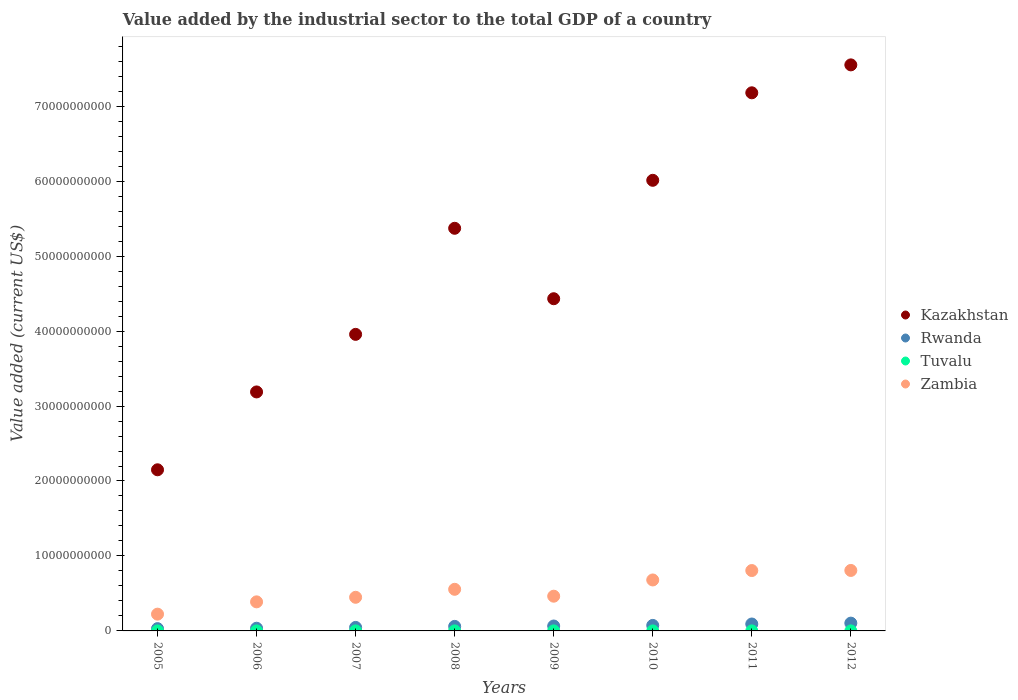How many different coloured dotlines are there?
Ensure brevity in your answer.  4. Is the number of dotlines equal to the number of legend labels?
Make the answer very short. Yes. What is the value added by the industrial sector to the total GDP in Kazakhstan in 2012?
Your response must be concise. 7.55e+1. Across all years, what is the maximum value added by the industrial sector to the total GDP in Zambia?
Offer a terse response. 8.07e+09. Across all years, what is the minimum value added by the industrial sector to the total GDP in Zambia?
Ensure brevity in your answer.  2.24e+09. What is the total value added by the industrial sector to the total GDP in Rwanda in the graph?
Your response must be concise. 5.09e+09. What is the difference between the value added by the industrial sector to the total GDP in Kazakhstan in 2009 and that in 2010?
Ensure brevity in your answer.  -1.58e+1. What is the difference between the value added by the industrial sector to the total GDP in Tuvalu in 2012 and the value added by the industrial sector to the total GDP in Rwanda in 2009?
Ensure brevity in your answer.  -6.52e+08. What is the average value added by the industrial sector to the total GDP in Rwanda per year?
Offer a very short reply. 6.36e+08. In the year 2006, what is the difference between the value added by the industrial sector to the total GDP in Zambia and value added by the industrial sector to the total GDP in Tuvalu?
Ensure brevity in your answer.  3.88e+09. In how many years, is the value added by the industrial sector to the total GDP in Kazakhstan greater than 24000000000 US$?
Your answer should be compact. 7. What is the ratio of the value added by the industrial sector to the total GDP in Tuvalu in 2005 to that in 2007?
Ensure brevity in your answer.  0.8. What is the difference between the highest and the second highest value added by the industrial sector to the total GDP in Kazakhstan?
Give a very brief answer. 3.73e+09. What is the difference between the highest and the lowest value added by the industrial sector to the total GDP in Kazakhstan?
Ensure brevity in your answer.  5.40e+1. Is it the case that in every year, the sum of the value added by the industrial sector to the total GDP in Kazakhstan and value added by the industrial sector to the total GDP in Rwanda  is greater than the value added by the industrial sector to the total GDP in Zambia?
Offer a terse response. Yes. Does the value added by the industrial sector to the total GDP in Tuvalu monotonically increase over the years?
Ensure brevity in your answer.  No. How many dotlines are there?
Provide a succinct answer. 4. What is the difference between two consecutive major ticks on the Y-axis?
Offer a terse response. 1.00e+1. Are the values on the major ticks of Y-axis written in scientific E-notation?
Make the answer very short. No. Does the graph contain any zero values?
Make the answer very short. No. Where does the legend appear in the graph?
Ensure brevity in your answer.  Center right. How many legend labels are there?
Give a very brief answer. 4. How are the legend labels stacked?
Offer a terse response. Vertical. What is the title of the graph?
Keep it short and to the point. Value added by the industrial sector to the total GDP of a country. Does "Europe(all income levels)" appear as one of the legend labels in the graph?
Make the answer very short. No. What is the label or title of the Y-axis?
Offer a terse response. Value added (current US$). What is the Value added (current US$) in Kazakhstan in 2005?
Your response must be concise. 2.15e+1. What is the Value added (current US$) in Rwanda in 2005?
Your answer should be compact. 3.05e+08. What is the Value added (current US$) in Tuvalu in 2005?
Your answer should be compact. 1.70e+06. What is the Value added (current US$) in Zambia in 2005?
Keep it short and to the point. 2.24e+09. What is the Value added (current US$) in Kazakhstan in 2006?
Your answer should be compact. 3.19e+1. What is the Value added (current US$) in Rwanda in 2006?
Provide a succinct answer. 3.59e+08. What is the Value added (current US$) in Tuvalu in 2006?
Your answer should be very brief. 1.30e+06. What is the Value added (current US$) in Zambia in 2006?
Offer a very short reply. 3.88e+09. What is the Value added (current US$) of Kazakhstan in 2007?
Your answer should be compact. 3.96e+1. What is the Value added (current US$) in Rwanda in 2007?
Provide a short and direct response. 4.68e+08. What is the Value added (current US$) in Tuvalu in 2007?
Your answer should be compact. 2.12e+06. What is the Value added (current US$) in Zambia in 2007?
Your response must be concise. 4.49e+09. What is the Value added (current US$) of Kazakhstan in 2008?
Keep it short and to the point. 5.37e+1. What is the Value added (current US$) in Rwanda in 2008?
Ensure brevity in your answer.  6.05e+08. What is the Value added (current US$) of Tuvalu in 2008?
Provide a succinct answer. 3.91e+06. What is the Value added (current US$) of Zambia in 2008?
Provide a succinct answer. 5.55e+09. What is the Value added (current US$) of Kazakhstan in 2009?
Provide a short and direct response. 4.43e+1. What is the Value added (current US$) in Rwanda in 2009?
Provide a short and direct response. 6.55e+08. What is the Value added (current US$) of Tuvalu in 2009?
Your response must be concise. 3.10e+06. What is the Value added (current US$) in Zambia in 2009?
Provide a succinct answer. 4.63e+09. What is the Value added (current US$) in Kazakhstan in 2010?
Your answer should be very brief. 6.01e+1. What is the Value added (current US$) in Rwanda in 2010?
Offer a very short reply. 7.34e+08. What is the Value added (current US$) in Tuvalu in 2010?
Provide a short and direct response. 1.77e+06. What is the Value added (current US$) in Zambia in 2010?
Make the answer very short. 6.80e+09. What is the Value added (current US$) of Kazakhstan in 2011?
Provide a short and direct response. 7.18e+1. What is the Value added (current US$) of Rwanda in 2011?
Your answer should be very brief. 9.23e+08. What is the Value added (current US$) of Tuvalu in 2011?
Keep it short and to the point. 3.49e+06. What is the Value added (current US$) in Zambia in 2011?
Give a very brief answer. 8.05e+09. What is the Value added (current US$) of Kazakhstan in 2012?
Make the answer very short. 7.55e+1. What is the Value added (current US$) in Rwanda in 2012?
Keep it short and to the point. 1.04e+09. What is the Value added (current US$) in Tuvalu in 2012?
Make the answer very short. 2.17e+06. What is the Value added (current US$) in Zambia in 2012?
Your response must be concise. 8.07e+09. Across all years, what is the maximum Value added (current US$) of Kazakhstan?
Ensure brevity in your answer.  7.55e+1. Across all years, what is the maximum Value added (current US$) in Rwanda?
Provide a short and direct response. 1.04e+09. Across all years, what is the maximum Value added (current US$) in Tuvalu?
Offer a terse response. 3.91e+06. Across all years, what is the maximum Value added (current US$) of Zambia?
Your answer should be very brief. 8.07e+09. Across all years, what is the minimum Value added (current US$) in Kazakhstan?
Your response must be concise. 2.15e+1. Across all years, what is the minimum Value added (current US$) of Rwanda?
Keep it short and to the point. 3.05e+08. Across all years, what is the minimum Value added (current US$) of Tuvalu?
Offer a terse response. 1.30e+06. Across all years, what is the minimum Value added (current US$) of Zambia?
Keep it short and to the point. 2.24e+09. What is the total Value added (current US$) in Kazakhstan in the graph?
Provide a succinct answer. 3.98e+11. What is the total Value added (current US$) in Rwanda in the graph?
Offer a very short reply. 5.09e+09. What is the total Value added (current US$) in Tuvalu in the graph?
Offer a very short reply. 1.96e+07. What is the total Value added (current US$) in Zambia in the graph?
Ensure brevity in your answer.  4.37e+1. What is the difference between the Value added (current US$) in Kazakhstan in 2005 and that in 2006?
Make the answer very short. -1.04e+1. What is the difference between the Value added (current US$) of Rwanda in 2005 and that in 2006?
Make the answer very short. -5.41e+07. What is the difference between the Value added (current US$) of Tuvalu in 2005 and that in 2006?
Your answer should be compact. 3.97e+05. What is the difference between the Value added (current US$) of Zambia in 2005 and that in 2006?
Your answer should be compact. -1.64e+09. What is the difference between the Value added (current US$) in Kazakhstan in 2005 and that in 2007?
Provide a succinct answer. -1.81e+1. What is the difference between the Value added (current US$) in Rwanda in 2005 and that in 2007?
Provide a short and direct response. -1.63e+08. What is the difference between the Value added (current US$) in Tuvalu in 2005 and that in 2007?
Offer a very short reply. -4.18e+05. What is the difference between the Value added (current US$) in Zambia in 2005 and that in 2007?
Offer a very short reply. -2.25e+09. What is the difference between the Value added (current US$) of Kazakhstan in 2005 and that in 2008?
Your response must be concise. -3.22e+1. What is the difference between the Value added (current US$) of Rwanda in 2005 and that in 2008?
Provide a succinct answer. -3.01e+08. What is the difference between the Value added (current US$) of Tuvalu in 2005 and that in 2008?
Provide a short and direct response. -2.21e+06. What is the difference between the Value added (current US$) of Zambia in 2005 and that in 2008?
Your response must be concise. -3.31e+09. What is the difference between the Value added (current US$) in Kazakhstan in 2005 and that in 2009?
Your response must be concise. -2.28e+1. What is the difference between the Value added (current US$) of Rwanda in 2005 and that in 2009?
Make the answer very short. -3.50e+08. What is the difference between the Value added (current US$) in Tuvalu in 2005 and that in 2009?
Give a very brief answer. -1.40e+06. What is the difference between the Value added (current US$) in Zambia in 2005 and that in 2009?
Ensure brevity in your answer.  -2.40e+09. What is the difference between the Value added (current US$) of Kazakhstan in 2005 and that in 2010?
Offer a very short reply. -3.86e+1. What is the difference between the Value added (current US$) of Rwanda in 2005 and that in 2010?
Make the answer very short. -4.29e+08. What is the difference between the Value added (current US$) of Tuvalu in 2005 and that in 2010?
Offer a terse response. -7.46e+04. What is the difference between the Value added (current US$) in Zambia in 2005 and that in 2010?
Make the answer very short. -4.56e+09. What is the difference between the Value added (current US$) of Kazakhstan in 2005 and that in 2011?
Ensure brevity in your answer.  -5.03e+1. What is the difference between the Value added (current US$) of Rwanda in 2005 and that in 2011?
Provide a short and direct response. -6.18e+08. What is the difference between the Value added (current US$) in Tuvalu in 2005 and that in 2011?
Provide a succinct answer. -1.79e+06. What is the difference between the Value added (current US$) of Zambia in 2005 and that in 2011?
Ensure brevity in your answer.  -5.82e+09. What is the difference between the Value added (current US$) in Kazakhstan in 2005 and that in 2012?
Give a very brief answer. -5.40e+1. What is the difference between the Value added (current US$) of Rwanda in 2005 and that in 2012?
Your answer should be compact. -7.34e+08. What is the difference between the Value added (current US$) of Tuvalu in 2005 and that in 2012?
Your answer should be very brief. -4.67e+05. What is the difference between the Value added (current US$) in Zambia in 2005 and that in 2012?
Provide a short and direct response. -5.83e+09. What is the difference between the Value added (current US$) in Kazakhstan in 2006 and that in 2007?
Your answer should be very brief. -7.68e+09. What is the difference between the Value added (current US$) in Rwanda in 2006 and that in 2007?
Keep it short and to the point. -1.09e+08. What is the difference between the Value added (current US$) in Tuvalu in 2006 and that in 2007?
Your answer should be very brief. -8.15e+05. What is the difference between the Value added (current US$) of Zambia in 2006 and that in 2007?
Offer a terse response. -6.08e+08. What is the difference between the Value added (current US$) in Kazakhstan in 2006 and that in 2008?
Your answer should be compact. -2.18e+1. What is the difference between the Value added (current US$) of Rwanda in 2006 and that in 2008?
Provide a succinct answer. -2.46e+08. What is the difference between the Value added (current US$) in Tuvalu in 2006 and that in 2008?
Ensure brevity in your answer.  -2.61e+06. What is the difference between the Value added (current US$) of Zambia in 2006 and that in 2008?
Make the answer very short. -1.67e+09. What is the difference between the Value added (current US$) of Kazakhstan in 2006 and that in 2009?
Make the answer very short. -1.24e+1. What is the difference between the Value added (current US$) of Rwanda in 2006 and that in 2009?
Provide a short and direct response. -2.96e+08. What is the difference between the Value added (current US$) of Tuvalu in 2006 and that in 2009?
Ensure brevity in your answer.  -1.80e+06. What is the difference between the Value added (current US$) in Zambia in 2006 and that in 2009?
Provide a short and direct response. -7.55e+08. What is the difference between the Value added (current US$) of Kazakhstan in 2006 and that in 2010?
Make the answer very short. -2.82e+1. What is the difference between the Value added (current US$) of Rwanda in 2006 and that in 2010?
Provide a succinct answer. -3.75e+08. What is the difference between the Value added (current US$) of Tuvalu in 2006 and that in 2010?
Your answer should be very brief. -4.72e+05. What is the difference between the Value added (current US$) in Zambia in 2006 and that in 2010?
Your answer should be compact. -2.92e+09. What is the difference between the Value added (current US$) of Kazakhstan in 2006 and that in 2011?
Ensure brevity in your answer.  -3.99e+1. What is the difference between the Value added (current US$) in Rwanda in 2006 and that in 2011?
Your answer should be very brief. -5.64e+08. What is the difference between the Value added (current US$) in Tuvalu in 2006 and that in 2011?
Offer a terse response. -2.18e+06. What is the difference between the Value added (current US$) of Zambia in 2006 and that in 2011?
Provide a succinct answer. -4.18e+09. What is the difference between the Value added (current US$) in Kazakhstan in 2006 and that in 2012?
Give a very brief answer. -4.36e+1. What is the difference between the Value added (current US$) in Rwanda in 2006 and that in 2012?
Offer a terse response. -6.80e+08. What is the difference between the Value added (current US$) in Tuvalu in 2006 and that in 2012?
Offer a terse response. -8.64e+05. What is the difference between the Value added (current US$) of Zambia in 2006 and that in 2012?
Keep it short and to the point. -4.19e+09. What is the difference between the Value added (current US$) of Kazakhstan in 2007 and that in 2008?
Ensure brevity in your answer.  -1.41e+1. What is the difference between the Value added (current US$) in Rwanda in 2007 and that in 2008?
Your response must be concise. -1.37e+08. What is the difference between the Value added (current US$) of Tuvalu in 2007 and that in 2008?
Your answer should be very brief. -1.79e+06. What is the difference between the Value added (current US$) of Zambia in 2007 and that in 2008?
Ensure brevity in your answer.  -1.07e+09. What is the difference between the Value added (current US$) in Kazakhstan in 2007 and that in 2009?
Your response must be concise. -4.75e+09. What is the difference between the Value added (current US$) in Rwanda in 2007 and that in 2009?
Ensure brevity in your answer.  -1.87e+08. What is the difference between the Value added (current US$) of Tuvalu in 2007 and that in 2009?
Keep it short and to the point. -9.82e+05. What is the difference between the Value added (current US$) of Zambia in 2007 and that in 2009?
Your answer should be compact. -1.47e+08. What is the difference between the Value added (current US$) of Kazakhstan in 2007 and that in 2010?
Offer a terse response. -2.06e+1. What is the difference between the Value added (current US$) in Rwanda in 2007 and that in 2010?
Provide a succinct answer. -2.66e+08. What is the difference between the Value added (current US$) in Tuvalu in 2007 and that in 2010?
Give a very brief answer. 3.43e+05. What is the difference between the Value added (current US$) of Zambia in 2007 and that in 2010?
Give a very brief answer. -2.31e+09. What is the difference between the Value added (current US$) of Kazakhstan in 2007 and that in 2011?
Provide a succinct answer. -3.22e+1. What is the difference between the Value added (current US$) in Rwanda in 2007 and that in 2011?
Provide a succinct answer. -4.55e+08. What is the difference between the Value added (current US$) of Tuvalu in 2007 and that in 2011?
Your answer should be very brief. -1.37e+06. What is the difference between the Value added (current US$) in Zambia in 2007 and that in 2011?
Your response must be concise. -3.57e+09. What is the difference between the Value added (current US$) of Kazakhstan in 2007 and that in 2012?
Ensure brevity in your answer.  -3.59e+1. What is the difference between the Value added (current US$) in Rwanda in 2007 and that in 2012?
Your answer should be very brief. -5.71e+08. What is the difference between the Value added (current US$) of Tuvalu in 2007 and that in 2012?
Your response must be concise. -4.91e+04. What is the difference between the Value added (current US$) in Zambia in 2007 and that in 2012?
Ensure brevity in your answer.  -3.58e+09. What is the difference between the Value added (current US$) of Kazakhstan in 2008 and that in 2009?
Provide a short and direct response. 9.40e+09. What is the difference between the Value added (current US$) in Rwanda in 2008 and that in 2009?
Give a very brief answer. -4.93e+07. What is the difference between the Value added (current US$) in Tuvalu in 2008 and that in 2009?
Provide a succinct answer. 8.09e+05. What is the difference between the Value added (current US$) in Zambia in 2008 and that in 2009?
Your response must be concise. 9.18e+08. What is the difference between the Value added (current US$) in Kazakhstan in 2008 and that in 2010?
Ensure brevity in your answer.  -6.40e+09. What is the difference between the Value added (current US$) of Rwanda in 2008 and that in 2010?
Your response must be concise. -1.29e+08. What is the difference between the Value added (current US$) in Tuvalu in 2008 and that in 2010?
Offer a terse response. 2.13e+06. What is the difference between the Value added (current US$) in Zambia in 2008 and that in 2010?
Your response must be concise. -1.25e+09. What is the difference between the Value added (current US$) of Kazakhstan in 2008 and that in 2011?
Provide a succinct answer. -1.81e+1. What is the difference between the Value added (current US$) in Rwanda in 2008 and that in 2011?
Make the answer very short. -3.18e+08. What is the difference between the Value added (current US$) of Tuvalu in 2008 and that in 2011?
Offer a terse response. 4.23e+05. What is the difference between the Value added (current US$) of Zambia in 2008 and that in 2011?
Make the answer very short. -2.50e+09. What is the difference between the Value added (current US$) of Kazakhstan in 2008 and that in 2012?
Your answer should be compact. -2.18e+1. What is the difference between the Value added (current US$) in Rwanda in 2008 and that in 2012?
Keep it short and to the point. -4.33e+08. What is the difference between the Value added (current US$) in Tuvalu in 2008 and that in 2012?
Ensure brevity in your answer.  1.74e+06. What is the difference between the Value added (current US$) of Zambia in 2008 and that in 2012?
Keep it short and to the point. -2.52e+09. What is the difference between the Value added (current US$) in Kazakhstan in 2009 and that in 2010?
Your answer should be very brief. -1.58e+1. What is the difference between the Value added (current US$) in Rwanda in 2009 and that in 2010?
Provide a succinct answer. -7.94e+07. What is the difference between the Value added (current US$) in Tuvalu in 2009 and that in 2010?
Your answer should be very brief. 1.33e+06. What is the difference between the Value added (current US$) in Zambia in 2009 and that in 2010?
Your answer should be compact. -2.16e+09. What is the difference between the Value added (current US$) in Kazakhstan in 2009 and that in 2011?
Offer a terse response. -2.75e+1. What is the difference between the Value added (current US$) in Rwanda in 2009 and that in 2011?
Provide a succinct answer. -2.68e+08. What is the difference between the Value added (current US$) of Tuvalu in 2009 and that in 2011?
Give a very brief answer. -3.86e+05. What is the difference between the Value added (current US$) of Zambia in 2009 and that in 2011?
Provide a short and direct response. -3.42e+09. What is the difference between the Value added (current US$) of Kazakhstan in 2009 and that in 2012?
Give a very brief answer. -3.12e+1. What is the difference between the Value added (current US$) of Rwanda in 2009 and that in 2012?
Your answer should be very brief. -3.84e+08. What is the difference between the Value added (current US$) in Tuvalu in 2009 and that in 2012?
Provide a succinct answer. 9.33e+05. What is the difference between the Value added (current US$) in Zambia in 2009 and that in 2012?
Ensure brevity in your answer.  -3.43e+09. What is the difference between the Value added (current US$) in Kazakhstan in 2010 and that in 2011?
Provide a succinct answer. -1.17e+1. What is the difference between the Value added (current US$) of Rwanda in 2010 and that in 2011?
Make the answer very short. -1.89e+08. What is the difference between the Value added (current US$) of Tuvalu in 2010 and that in 2011?
Your answer should be compact. -1.71e+06. What is the difference between the Value added (current US$) in Zambia in 2010 and that in 2011?
Ensure brevity in your answer.  -1.26e+09. What is the difference between the Value added (current US$) in Kazakhstan in 2010 and that in 2012?
Offer a terse response. -1.54e+1. What is the difference between the Value added (current US$) in Rwanda in 2010 and that in 2012?
Keep it short and to the point. -3.05e+08. What is the difference between the Value added (current US$) in Tuvalu in 2010 and that in 2012?
Your response must be concise. -3.92e+05. What is the difference between the Value added (current US$) of Zambia in 2010 and that in 2012?
Your response must be concise. -1.27e+09. What is the difference between the Value added (current US$) in Kazakhstan in 2011 and that in 2012?
Your answer should be very brief. -3.73e+09. What is the difference between the Value added (current US$) of Rwanda in 2011 and that in 2012?
Provide a succinct answer. -1.16e+08. What is the difference between the Value added (current US$) in Tuvalu in 2011 and that in 2012?
Your answer should be very brief. 1.32e+06. What is the difference between the Value added (current US$) of Zambia in 2011 and that in 2012?
Offer a very short reply. -1.27e+07. What is the difference between the Value added (current US$) in Kazakhstan in 2005 and the Value added (current US$) in Rwanda in 2006?
Your answer should be very brief. 2.11e+1. What is the difference between the Value added (current US$) of Kazakhstan in 2005 and the Value added (current US$) of Tuvalu in 2006?
Your answer should be compact. 2.15e+1. What is the difference between the Value added (current US$) in Kazakhstan in 2005 and the Value added (current US$) in Zambia in 2006?
Your response must be concise. 1.76e+1. What is the difference between the Value added (current US$) in Rwanda in 2005 and the Value added (current US$) in Tuvalu in 2006?
Provide a short and direct response. 3.03e+08. What is the difference between the Value added (current US$) of Rwanda in 2005 and the Value added (current US$) of Zambia in 2006?
Provide a short and direct response. -3.57e+09. What is the difference between the Value added (current US$) in Tuvalu in 2005 and the Value added (current US$) in Zambia in 2006?
Make the answer very short. -3.88e+09. What is the difference between the Value added (current US$) in Kazakhstan in 2005 and the Value added (current US$) in Rwanda in 2007?
Provide a succinct answer. 2.10e+1. What is the difference between the Value added (current US$) in Kazakhstan in 2005 and the Value added (current US$) in Tuvalu in 2007?
Give a very brief answer. 2.15e+1. What is the difference between the Value added (current US$) in Kazakhstan in 2005 and the Value added (current US$) in Zambia in 2007?
Keep it short and to the point. 1.70e+1. What is the difference between the Value added (current US$) in Rwanda in 2005 and the Value added (current US$) in Tuvalu in 2007?
Your answer should be very brief. 3.03e+08. What is the difference between the Value added (current US$) in Rwanda in 2005 and the Value added (current US$) in Zambia in 2007?
Ensure brevity in your answer.  -4.18e+09. What is the difference between the Value added (current US$) of Tuvalu in 2005 and the Value added (current US$) of Zambia in 2007?
Make the answer very short. -4.48e+09. What is the difference between the Value added (current US$) in Kazakhstan in 2005 and the Value added (current US$) in Rwanda in 2008?
Give a very brief answer. 2.09e+1. What is the difference between the Value added (current US$) in Kazakhstan in 2005 and the Value added (current US$) in Tuvalu in 2008?
Your answer should be very brief. 2.15e+1. What is the difference between the Value added (current US$) of Kazakhstan in 2005 and the Value added (current US$) of Zambia in 2008?
Your answer should be very brief. 1.59e+1. What is the difference between the Value added (current US$) of Rwanda in 2005 and the Value added (current US$) of Tuvalu in 2008?
Ensure brevity in your answer.  3.01e+08. What is the difference between the Value added (current US$) of Rwanda in 2005 and the Value added (current US$) of Zambia in 2008?
Offer a very short reply. -5.25e+09. What is the difference between the Value added (current US$) in Tuvalu in 2005 and the Value added (current US$) in Zambia in 2008?
Give a very brief answer. -5.55e+09. What is the difference between the Value added (current US$) of Kazakhstan in 2005 and the Value added (current US$) of Rwanda in 2009?
Keep it short and to the point. 2.08e+1. What is the difference between the Value added (current US$) of Kazakhstan in 2005 and the Value added (current US$) of Tuvalu in 2009?
Offer a very short reply. 2.15e+1. What is the difference between the Value added (current US$) of Kazakhstan in 2005 and the Value added (current US$) of Zambia in 2009?
Offer a terse response. 1.69e+1. What is the difference between the Value added (current US$) of Rwanda in 2005 and the Value added (current US$) of Tuvalu in 2009?
Ensure brevity in your answer.  3.02e+08. What is the difference between the Value added (current US$) of Rwanda in 2005 and the Value added (current US$) of Zambia in 2009?
Your answer should be compact. -4.33e+09. What is the difference between the Value added (current US$) of Tuvalu in 2005 and the Value added (current US$) of Zambia in 2009?
Provide a short and direct response. -4.63e+09. What is the difference between the Value added (current US$) of Kazakhstan in 2005 and the Value added (current US$) of Rwanda in 2010?
Ensure brevity in your answer.  2.08e+1. What is the difference between the Value added (current US$) of Kazakhstan in 2005 and the Value added (current US$) of Tuvalu in 2010?
Your answer should be compact. 2.15e+1. What is the difference between the Value added (current US$) of Kazakhstan in 2005 and the Value added (current US$) of Zambia in 2010?
Offer a terse response. 1.47e+1. What is the difference between the Value added (current US$) in Rwanda in 2005 and the Value added (current US$) in Tuvalu in 2010?
Your response must be concise. 3.03e+08. What is the difference between the Value added (current US$) in Rwanda in 2005 and the Value added (current US$) in Zambia in 2010?
Offer a very short reply. -6.49e+09. What is the difference between the Value added (current US$) of Tuvalu in 2005 and the Value added (current US$) of Zambia in 2010?
Your response must be concise. -6.80e+09. What is the difference between the Value added (current US$) in Kazakhstan in 2005 and the Value added (current US$) in Rwanda in 2011?
Provide a short and direct response. 2.06e+1. What is the difference between the Value added (current US$) in Kazakhstan in 2005 and the Value added (current US$) in Tuvalu in 2011?
Offer a terse response. 2.15e+1. What is the difference between the Value added (current US$) of Kazakhstan in 2005 and the Value added (current US$) of Zambia in 2011?
Ensure brevity in your answer.  1.34e+1. What is the difference between the Value added (current US$) in Rwanda in 2005 and the Value added (current US$) in Tuvalu in 2011?
Ensure brevity in your answer.  3.01e+08. What is the difference between the Value added (current US$) in Rwanda in 2005 and the Value added (current US$) in Zambia in 2011?
Provide a short and direct response. -7.75e+09. What is the difference between the Value added (current US$) in Tuvalu in 2005 and the Value added (current US$) in Zambia in 2011?
Ensure brevity in your answer.  -8.05e+09. What is the difference between the Value added (current US$) in Kazakhstan in 2005 and the Value added (current US$) in Rwanda in 2012?
Ensure brevity in your answer.  2.05e+1. What is the difference between the Value added (current US$) in Kazakhstan in 2005 and the Value added (current US$) in Tuvalu in 2012?
Ensure brevity in your answer.  2.15e+1. What is the difference between the Value added (current US$) in Kazakhstan in 2005 and the Value added (current US$) in Zambia in 2012?
Your answer should be compact. 1.34e+1. What is the difference between the Value added (current US$) of Rwanda in 2005 and the Value added (current US$) of Tuvalu in 2012?
Make the answer very short. 3.03e+08. What is the difference between the Value added (current US$) in Rwanda in 2005 and the Value added (current US$) in Zambia in 2012?
Your answer should be very brief. -7.76e+09. What is the difference between the Value added (current US$) of Tuvalu in 2005 and the Value added (current US$) of Zambia in 2012?
Provide a succinct answer. -8.07e+09. What is the difference between the Value added (current US$) of Kazakhstan in 2006 and the Value added (current US$) of Rwanda in 2007?
Provide a succinct answer. 3.14e+1. What is the difference between the Value added (current US$) in Kazakhstan in 2006 and the Value added (current US$) in Tuvalu in 2007?
Offer a very short reply. 3.19e+1. What is the difference between the Value added (current US$) of Kazakhstan in 2006 and the Value added (current US$) of Zambia in 2007?
Provide a succinct answer. 2.74e+1. What is the difference between the Value added (current US$) in Rwanda in 2006 and the Value added (current US$) in Tuvalu in 2007?
Your answer should be compact. 3.57e+08. What is the difference between the Value added (current US$) in Rwanda in 2006 and the Value added (current US$) in Zambia in 2007?
Provide a succinct answer. -4.13e+09. What is the difference between the Value added (current US$) in Tuvalu in 2006 and the Value added (current US$) in Zambia in 2007?
Make the answer very short. -4.48e+09. What is the difference between the Value added (current US$) in Kazakhstan in 2006 and the Value added (current US$) in Rwanda in 2008?
Your answer should be compact. 3.13e+1. What is the difference between the Value added (current US$) in Kazakhstan in 2006 and the Value added (current US$) in Tuvalu in 2008?
Make the answer very short. 3.19e+1. What is the difference between the Value added (current US$) of Kazakhstan in 2006 and the Value added (current US$) of Zambia in 2008?
Provide a short and direct response. 2.63e+1. What is the difference between the Value added (current US$) in Rwanda in 2006 and the Value added (current US$) in Tuvalu in 2008?
Offer a terse response. 3.55e+08. What is the difference between the Value added (current US$) in Rwanda in 2006 and the Value added (current US$) in Zambia in 2008?
Ensure brevity in your answer.  -5.19e+09. What is the difference between the Value added (current US$) of Tuvalu in 2006 and the Value added (current US$) of Zambia in 2008?
Provide a succinct answer. -5.55e+09. What is the difference between the Value added (current US$) of Kazakhstan in 2006 and the Value added (current US$) of Rwanda in 2009?
Give a very brief answer. 3.12e+1. What is the difference between the Value added (current US$) of Kazakhstan in 2006 and the Value added (current US$) of Tuvalu in 2009?
Provide a short and direct response. 3.19e+1. What is the difference between the Value added (current US$) of Kazakhstan in 2006 and the Value added (current US$) of Zambia in 2009?
Make the answer very short. 2.72e+1. What is the difference between the Value added (current US$) in Rwanda in 2006 and the Value added (current US$) in Tuvalu in 2009?
Your answer should be very brief. 3.56e+08. What is the difference between the Value added (current US$) of Rwanda in 2006 and the Value added (current US$) of Zambia in 2009?
Your answer should be compact. -4.27e+09. What is the difference between the Value added (current US$) in Tuvalu in 2006 and the Value added (current US$) in Zambia in 2009?
Your answer should be very brief. -4.63e+09. What is the difference between the Value added (current US$) in Kazakhstan in 2006 and the Value added (current US$) in Rwanda in 2010?
Ensure brevity in your answer.  3.11e+1. What is the difference between the Value added (current US$) of Kazakhstan in 2006 and the Value added (current US$) of Tuvalu in 2010?
Provide a succinct answer. 3.19e+1. What is the difference between the Value added (current US$) in Kazakhstan in 2006 and the Value added (current US$) in Zambia in 2010?
Offer a terse response. 2.51e+1. What is the difference between the Value added (current US$) in Rwanda in 2006 and the Value added (current US$) in Tuvalu in 2010?
Give a very brief answer. 3.57e+08. What is the difference between the Value added (current US$) of Rwanda in 2006 and the Value added (current US$) of Zambia in 2010?
Provide a succinct answer. -6.44e+09. What is the difference between the Value added (current US$) in Tuvalu in 2006 and the Value added (current US$) in Zambia in 2010?
Your answer should be very brief. -6.80e+09. What is the difference between the Value added (current US$) of Kazakhstan in 2006 and the Value added (current US$) of Rwanda in 2011?
Provide a short and direct response. 3.10e+1. What is the difference between the Value added (current US$) in Kazakhstan in 2006 and the Value added (current US$) in Tuvalu in 2011?
Keep it short and to the point. 3.19e+1. What is the difference between the Value added (current US$) of Kazakhstan in 2006 and the Value added (current US$) of Zambia in 2011?
Offer a terse response. 2.38e+1. What is the difference between the Value added (current US$) in Rwanda in 2006 and the Value added (current US$) in Tuvalu in 2011?
Your answer should be very brief. 3.55e+08. What is the difference between the Value added (current US$) in Rwanda in 2006 and the Value added (current US$) in Zambia in 2011?
Give a very brief answer. -7.70e+09. What is the difference between the Value added (current US$) in Tuvalu in 2006 and the Value added (current US$) in Zambia in 2011?
Offer a very short reply. -8.05e+09. What is the difference between the Value added (current US$) in Kazakhstan in 2006 and the Value added (current US$) in Rwanda in 2012?
Provide a short and direct response. 3.08e+1. What is the difference between the Value added (current US$) of Kazakhstan in 2006 and the Value added (current US$) of Tuvalu in 2012?
Offer a very short reply. 3.19e+1. What is the difference between the Value added (current US$) in Kazakhstan in 2006 and the Value added (current US$) in Zambia in 2012?
Provide a short and direct response. 2.38e+1. What is the difference between the Value added (current US$) of Rwanda in 2006 and the Value added (current US$) of Tuvalu in 2012?
Offer a terse response. 3.57e+08. What is the difference between the Value added (current US$) in Rwanda in 2006 and the Value added (current US$) in Zambia in 2012?
Keep it short and to the point. -7.71e+09. What is the difference between the Value added (current US$) of Tuvalu in 2006 and the Value added (current US$) of Zambia in 2012?
Make the answer very short. -8.07e+09. What is the difference between the Value added (current US$) in Kazakhstan in 2007 and the Value added (current US$) in Rwanda in 2008?
Keep it short and to the point. 3.90e+1. What is the difference between the Value added (current US$) of Kazakhstan in 2007 and the Value added (current US$) of Tuvalu in 2008?
Your response must be concise. 3.96e+1. What is the difference between the Value added (current US$) in Kazakhstan in 2007 and the Value added (current US$) in Zambia in 2008?
Your answer should be very brief. 3.40e+1. What is the difference between the Value added (current US$) of Rwanda in 2007 and the Value added (current US$) of Tuvalu in 2008?
Offer a very short reply. 4.64e+08. What is the difference between the Value added (current US$) in Rwanda in 2007 and the Value added (current US$) in Zambia in 2008?
Give a very brief answer. -5.08e+09. What is the difference between the Value added (current US$) in Tuvalu in 2007 and the Value added (current US$) in Zambia in 2008?
Your answer should be very brief. -5.55e+09. What is the difference between the Value added (current US$) of Kazakhstan in 2007 and the Value added (current US$) of Rwanda in 2009?
Provide a short and direct response. 3.89e+1. What is the difference between the Value added (current US$) of Kazakhstan in 2007 and the Value added (current US$) of Tuvalu in 2009?
Your response must be concise. 3.96e+1. What is the difference between the Value added (current US$) in Kazakhstan in 2007 and the Value added (current US$) in Zambia in 2009?
Provide a succinct answer. 3.49e+1. What is the difference between the Value added (current US$) of Rwanda in 2007 and the Value added (current US$) of Tuvalu in 2009?
Your answer should be very brief. 4.65e+08. What is the difference between the Value added (current US$) of Rwanda in 2007 and the Value added (current US$) of Zambia in 2009?
Ensure brevity in your answer.  -4.16e+09. What is the difference between the Value added (current US$) in Tuvalu in 2007 and the Value added (current US$) in Zambia in 2009?
Your response must be concise. -4.63e+09. What is the difference between the Value added (current US$) in Kazakhstan in 2007 and the Value added (current US$) in Rwanda in 2010?
Give a very brief answer. 3.88e+1. What is the difference between the Value added (current US$) in Kazakhstan in 2007 and the Value added (current US$) in Tuvalu in 2010?
Offer a terse response. 3.96e+1. What is the difference between the Value added (current US$) of Kazakhstan in 2007 and the Value added (current US$) of Zambia in 2010?
Make the answer very short. 3.28e+1. What is the difference between the Value added (current US$) of Rwanda in 2007 and the Value added (current US$) of Tuvalu in 2010?
Make the answer very short. 4.66e+08. What is the difference between the Value added (current US$) in Rwanda in 2007 and the Value added (current US$) in Zambia in 2010?
Offer a terse response. -6.33e+09. What is the difference between the Value added (current US$) of Tuvalu in 2007 and the Value added (current US$) of Zambia in 2010?
Your answer should be very brief. -6.80e+09. What is the difference between the Value added (current US$) of Kazakhstan in 2007 and the Value added (current US$) of Rwanda in 2011?
Your answer should be very brief. 3.86e+1. What is the difference between the Value added (current US$) of Kazakhstan in 2007 and the Value added (current US$) of Tuvalu in 2011?
Offer a very short reply. 3.96e+1. What is the difference between the Value added (current US$) of Kazakhstan in 2007 and the Value added (current US$) of Zambia in 2011?
Make the answer very short. 3.15e+1. What is the difference between the Value added (current US$) in Rwanda in 2007 and the Value added (current US$) in Tuvalu in 2011?
Your response must be concise. 4.65e+08. What is the difference between the Value added (current US$) of Rwanda in 2007 and the Value added (current US$) of Zambia in 2011?
Provide a short and direct response. -7.59e+09. What is the difference between the Value added (current US$) of Tuvalu in 2007 and the Value added (current US$) of Zambia in 2011?
Offer a terse response. -8.05e+09. What is the difference between the Value added (current US$) in Kazakhstan in 2007 and the Value added (current US$) in Rwanda in 2012?
Give a very brief answer. 3.85e+1. What is the difference between the Value added (current US$) in Kazakhstan in 2007 and the Value added (current US$) in Tuvalu in 2012?
Offer a terse response. 3.96e+1. What is the difference between the Value added (current US$) of Kazakhstan in 2007 and the Value added (current US$) of Zambia in 2012?
Your response must be concise. 3.15e+1. What is the difference between the Value added (current US$) in Rwanda in 2007 and the Value added (current US$) in Tuvalu in 2012?
Offer a terse response. 4.66e+08. What is the difference between the Value added (current US$) of Rwanda in 2007 and the Value added (current US$) of Zambia in 2012?
Provide a succinct answer. -7.60e+09. What is the difference between the Value added (current US$) of Tuvalu in 2007 and the Value added (current US$) of Zambia in 2012?
Your response must be concise. -8.06e+09. What is the difference between the Value added (current US$) in Kazakhstan in 2008 and the Value added (current US$) in Rwanda in 2009?
Keep it short and to the point. 5.31e+1. What is the difference between the Value added (current US$) in Kazakhstan in 2008 and the Value added (current US$) in Tuvalu in 2009?
Offer a terse response. 5.37e+1. What is the difference between the Value added (current US$) in Kazakhstan in 2008 and the Value added (current US$) in Zambia in 2009?
Your answer should be compact. 4.91e+1. What is the difference between the Value added (current US$) of Rwanda in 2008 and the Value added (current US$) of Tuvalu in 2009?
Ensure brevity in your answer.  6.02e+08. What is the difference between the Value added (current US$) of Rwanda in 2008 and the Value added (current US$) of Zambia in 2009?
Your answer should be very brief. -4.03e+09. What is the difference between the Value added (current US$) in Tuvalu in 2008 and the Value added (current US$) in Zambia in 2009?
Ensure brevity in your answer.  -4.63e+09. What is the difference between the Value added (current US$) in Kazakhstan in 2008 and the Value added (current US$) in Rwanda in 2010?
Make the answer very short. 5.30e+1. What is the difference between the Value added (current US$) of Kazakhstan in 2008 and the Value added (current US$) of Tuvalu in 2010?
Keep it short and to the point. 5.37e+1. What is the difference between the Value added (current US$) of Kazakhstan in 2008 and the Value added (current US$) of Zambia in 2010?
Your response must be concise. 4.69e+1. What is the difference between the Value added (current US$) in Rwanda in 2008 and the Value added (current US$) in Tuvalu in 2010?
Your answer should be compact. 6.04e+08. What is the difference between the Value added (current US$) in Rwanda in 2008 and the Value added (current US$) in Zambia in 2010?
Keep it short and to the point. -6.19e+09. What is the difference between the Value added (current US$) of Tuvalu in 2008 and the Value added (current US$) of Zambia in 2010?
Offer a terse response. -6.79e+09. What is the difference between the Value added (current US$) in Kazakhstan in 2008 and the Value added (current US$) in Rwanda in 2011?
Give a very brief answer. 5.28e+1. What is the difference between the Value added (current US$) of Kazakhstan in 2008 and the Value added (current US$) of Tuvalu in 2011?
Your answer should be very brief. 5.37e+1. What is the difference between the Value added (current US$) of Kazakhstan in 2008 and the Value added (current US$) of Zambia in 2011?
Make the answer very short. 4.57e+1. What is the difference between the Value added (current US$) in Rwanda in 2008 and the Value added (current US$) in Tuvalu in 2011?
Offer a very short reply. 6.02e+08. What is the difference between the Value added (current US$) of Rwanda in 2008 and the Value added (current US$) of Zambia in 2011?
Your response must be concise. -7.45e+09. What is the difference between the Value added (current US$) of Tuvalu in 2008 and the Value added (current US$) of Zambia in 2011?
Your response must be concise. -8.05e+09. What is the difference between the Value added (current US$) in Kazakhstan in 2008 and the Value added (current US$) in Rwanda in 2012?
Offer a very short reply. 5.27e+1. What is the difference between the Value added (current US$) of Kazakhstan in 2008 and the Value added (current US$) of Tuvalu in 2012?
Offer a terse response. 5.37e+1. What is the difference between the Value added (current US$) of Kazakhstan in 2008 and the Value added (current US$) of Zambia in 2012?
Provide a succinct answer. 4.56e+1. What is the difference between the Value added (current US$) of Rwanda in 2008 and the Value added (current US$) of Tuvalu in 2012?
Your answer should be compact. 6.03e+08. What is the difference between the Value added (current US$) of Rwanda in 2008 and the Value added (current US$) of Zambia in 2012?
Your answer should be compact. -7.46e+09. What is the difference between the Value added (current US$) in Tuvalu in 2008 and the Value added (current US$) in Zambia in 2012?
Your answer should be very brief. -8.06e+09. What is the difference between the Value added (current US$) in Kazakhstan in 2009 and the Value added (current US$) in Rwanda in 2010?
Offer a very short reply. 4.36e+1. What is the difference between the Value added (current US$) of Kazakhstan in 2009 and the Value added (current US$) of Tuvalu in 2010?
Keep it short and to the point. 4.43e+1. What is the difference between the Value added (current US$) of Kazakhstan in 2009 and the Value added (current US$) of Zambia in 2010?
Ensure brevity in your answer.  3.75e+1. What is the difference between the Value added (current US$) of Rwanda in 2009 and the Value added (current US$) of Tuvalu in 2010?
Give a very brief answer. 6.53e+08. What is the difference between the Value added (current US$) in Rwanda in 2009 and the Value added (current US$) in Zambia in 2010?
Provide a short and direct response. -6.14e+09. What is the difference between the Value added (current US$) of Tuvalu in 2009 and the Value added (current US$) of Zambia in 2010?
Your answer should be very brief. -6.79e+09. What is the difference between the Value added (current US$) in Kazakhstan in 2009 and the Value added (current US$) in Rwanda in 2011?
Keep it short and to the point. 4.34e+1. What is the difference between the Value added (current US$) of Kazakhstan in 2009 and the Value added (current US$) of Tuvalu in 2011?
Ensure brevity in your answer.  4.43e+1. What is the difference between the Value added (current US$) in Kazakhstan in 2009 and the Value added (current US$) in Zambia in 2011?
Keep it short and to the point. 3.63e+1. What is the difference between the Value added (current US$) in Rwanda in 2009 and the Value added (current US$) in Tuvalu in 2011?
Offer a terse response. 6.51e+08. What is the difference between the Value added (current US$) in Rwanda in 2009 and the Value added (current US$) in Zambia in 2011?
Provide a short and direct response. -7.40e+09. What is the difference between the Value added (current US$) in Tuvalu in 2009 and the Value added (current US$) in Zambia in 2011?
Offer a very short reply. -8.05e+09. What is the difference between the Value added (current US$) in Kazakhstan in 2009 and the Value added (current US$) in Rwanda in 2012?
Your response must be concise. 4.33e+1. What is the difference between the Value added (current US$) in Kazakhstan in 2009 and the Value added (current US$) in Tuvalu in 2012?
Give a very brief answer. 4.43e+1. What is the difference between the Value added (current US$) in Kazakhstan in 2009 and the Value added (current US$) in Zambia in 2012?
Offer a terse response. 3.62e+1. What is the difference between the Value added (current US$) of Rwanda in 2009 and the Value added (current US$) of Tuvalu in 2012?
Offer a terse response. 6.52e+08. What is the difference between the Value added (current US$) in Rwanda in 2009 and the Value added (current US$) in Zambia in 2012?
Make the answer very short. -7.41e+09. What is the difference between the Value added (current US$) in Tuvalu in 2009 and the Value added (current US$) in Zambia in 2012?
Your response must be concise. -8.06e+09. What is the difference between the Value added (current US$) in Kazakhstan in 2010 and the Value added (current US$) in Rwanda in 2011?
Provide a short and direct response. 5.92e+1. What is the difference between the Value added (current US$) in Kazakhstan in 2010 and the Value added (current US$) in Tuvalu in 2011?
Your response must be concise. 6.01e+1. What is the difference between the Value added (current US$) in Kazakhstan in 2010 and the Value added (current US$) in Zambia in 2011?
Ensure brevity in your answer.  5.21e+1. What is the difference between the Value added (current US$) of Rwanda in 2010 and the Value added (current US$) of Tuvalu in 2011?
Offer a terse response. 7.30e+08. What is the difference between the Value added (current US$) in Rwanda in 2010 and the Value added (current US$) in Zambia in 2011?
Keep it short and to the point. -7.32e+09. What is the difference between the Value added (current US$) in Tuvalu in 2010 and the Value added (current US$) in Zambia in 2011?
Make the answer very short. -8.05e+09. What is the difference between the Value added (current US$) of Kazakhstan in 2010 and the Value added (current US$) of Rwanda in 2012?
Your answer should be compact. 5.91e+1. What is the difference between the Value added (current US$) of Kazakhstan in 2010 and the Value added (current US$) of Tuvalu in 2012?
Your response must be concise. 6.01e+1. What is the difference between the Value added (current US$) in Kazakhstan in 2010 and the Value added (current US$) in Zambia in 2012?
Offer a terse response. 5.20e+1. What is the difference between the Value added (current US$) of Rwanda in 2010 and the Value added (current US$) of Tuvalu in 2012?
Your answer should be compact. 7.32e+08. What is the difference between the Value added (current US$) in Rwanda in 2010 and the Value added (current US$) in Zambia in 2012?
Your answer should be very brief. -7.33e+09. What is the difference between the Value added (current US$) of Tuvalu in 2010 and the Value added (current US$) of Zambia in 2012?
Make the answer very short. -8.07e+09. What is the difference between the Value added (current US$) of Kazakhstan in 2011 and the Value added (current US$) of Rwanda in 2012?
Your response must be concise. 7.07e+1. What is the difference between the Value added (current US$) in Kazakhstan in 2011 and the Value added (current US$) in Tuvalu in 2012?
Provide a short and direct response. 7.18e+1. What is the difference between the Value added (current US$) in Kazakhstan in 2011 and the Value added (current US$) in Zambia in 2012?
Provide a succinct answer. 6.37e+1. What is the difference between the Value added (current US$) in Rwanda in 2011 and the Value added (current US$) in Tuvalu in 2012?
Offer a very short reply. 9.21e+08. What is the difference between the Value added (current US$) in Rwanda in 2011 and the Value added (current US$) in Zambia in 2012?
Your answer should be compact. -7.14e+09. What is the difference between the Value added (current US$) in Tuvalu in 2011 and the Value added (current US$) in Zambia in 2012?
Give a very brief answer. -8.06e+09. What is the average Value added (current US$) of Kazakhstan per year?
Your answer should be very brief. 4.98e+1. What is the average Value added (current US$) in Rwanda per year?
Your response must be concise. 6.36e+08. What is the average Value added (current US$) of Tuvalu per year?
Make the answer very short. 2.44e+06. What is the average Value added (current US$) in Zambia per year?
Keep it short and to the point. 5.46e+09. In the year 2005, what is the difference between the Value added (current US$) in Kazakhstan and Value added (current US$) in Rwanda?
Keep it short and to the point. 2.12e+1. In the year 2005, what is the difference between the Value added (current US$) of Kazakhstan and Value added (current US$) of Tuvalu?
Your answer should be very brief. 2.15e+1. In the year 2005, what is the difference between the Value added (current US$) of Kazakhstan and Value added (current US$) of Zambia?
Give a very brief answer. 1.93e+1. In the year 2005, what is the difference between the Value added (current US$) in Rwanda and Value added (current US$) in Tuvalu?
Offer a very short reply. 3.03e+08. In the year 2005, what is the difference between the Value added (current US$) in Rwanda and Value added (current US$) in Zambia?
Your answer should be very brief. -1.93e+09. In the year 2005, what is the difference between the Value added (current US$) in Tuvalu and Value added (current US$) in Zambia?
Your answer should be very brief. -2.24e+09. In the year 2006, what is the difference between the Value added (current US$) of Kazakhstan and Value added (current US$) of Rwanda?
Ensure brevity in your answer.  3.15e+1. In the year 2006, what is the difference between the Value added (current US$) of Kazakhstan and Value added (current US$) of Tuvalu?
Offer a very short reply. 3.19e+1. In the year 2006, what is the difference between the Value added (current US$) in Kazakhstan and Value added (current US$) in Zambia?
Your answer should be compact. 2.80e+1. In the year 2006, what is the difference between the Value added (current US$) in Rwanda and Value added (current US$) in Tuvalu?
Give a very brief answer. 3.58e+08. In the year 2006, what is the difference between the Value added (current US$) of Rwanda and Value added (current US$) of Zambia?
Your answer should be very brief. -3.52e+09. In the year 2006, what is the difference between the Value added (current US$) in Tuvalu and Value added (current US$) in Zambia?
Make the answer very short. -3.88e+09. In the year 2007, what is the difference between the Value added (current US$) in Kazakhstan and Value added (current US$) in Rwanda?
Your answer should be compact. 3.91e+1. In the year 2007, what is the difference between the Value added (current US$) in Kazakhstan and Value added (current US$) in Tuvalu?
Make the answer very short. 3.96e+1. In the year 2007, what is the difference between the Value added (current US$) in Kazakhstan and Value added (current US$) in Zambia?
Offer a terse response. 3.51e+1. In the year 2007, what is the difference between the Value added (current US$) of Rwanda and Value added (current US$) of Tuvalu?
Give a very brief answer. 4.66e+08. In the year 2007, what is the difference between the Value added (current US$) in Rwanda and Value added (current US$) in Zambia?
Keep it short and to the point. -4.02e+09. In the year 2007, what is the difference between the Value added (current US$) of Tuvalu and Value added (current US$) of Zambia?
Ensure brevity in your answer.  -4.48e+09. In the year 2008, what is the difference between the Value added (current US$) in Kazakhstan and Value added (current US$) in Rwanda?
Make the answer very short. 5.31e+1. In the year 2008, what is the difference between the Value added (current US$) in Kazakhstan and Value added (current US$) in Tuvalu?
Your response must be concise. 5.37e+1. In the year 2008, what is the difference between the Value added (current US$) in Kazakhstan and Value added (current US$) in Zambia?
Your response must be concise. 4.82e+1. In the year 2008, what is the difference between the Value added (current US$) in Rwanda and Value added (current US$) in Tuvalu?
Keep it short and to the point. 6.01e+08. In the year 2008, what is the difference between the Value added (current US$) of Rwanda and Value added (current US$) of Zambia?
Keep it short and to the point. -4.95e+09. In the year 2008, what is the difference between the Value added (current US$) in Tuvalu and Value added (current US$) in Zambia?
Your answer should be very brief. -5.55e+09. In the year 2009, what is the difference between the Value added (current US$) in Kazakhstan and Value added (current US$) in Rwanda?
Provide a short and direct response. 4.37e+1. In the year 2009, what is the difference between the Value added (current US$) of Kazakhstan and Value added (current US$) of Tuvalu?
Ensure brevity in your answer.  4.43e+1. In the year 2009, what is the difference between the Value added (current US$) of Kazakhstan and Value added (current US$) of Zambia?
Give a very brief answer. 3.97e+1. In the year 2009, what is the difference between the Value added (current US$) of Rwanda and Value added (current US$) of Tuvalu?
Give a very brief answer. 6.52e+08. In the year 2009, what is the difference between the Value added (current US$) in Rwanda and Value added (current US$) in Zambia?
Your answer should be compact. -3.98e+09. In the year 2009, what is the difference between the Value added (current US$) in Tuvalu and Value added (current US$) in Zambia?
Keep it short and to the point. -4.63e+09. In the year 2010, what is the difference between the Value added (current US$) of Kazakhstan and Value added (current US$) of Rwanda?
Give a very brief answer. 5.94e+1. In the year 2010, what is the difference between the Value added (current US$) in Kazakhstan and Value added (current US$) in Tuvalu?
Offer a very short reply. 6.01e+1. In the year 2010, what is the difference between the Value added (current US$) of Kazakhstan and Value added (current US$) of Zambia?
Give a very brief answer. 5.33e+1. In the year 2010, what is the difference between the Value added (current US$) in Rwanda and Value added (current US$) in Tuvalu?
Keep it short and to the point. 7.32e+08. In the year 2010, what is the difference between the Value added (current US$) in Rwanda and Value added (current US$) in Zambia?
Offer a terse response. -6.06e+09. In the year 2010, what is the difference between the Value added (current US$) of Tuvalu and Value added (current US$) of Zambia?
Offer a very short reply. -6.80e+09. In the year 2011, what is the difference between the Value added (current US$) of Kazakhstan and Value added (current US$) of Rwanda?
Offer a very short reply. 7.09e+1. In the year 2011, what is the difference between the Value added (current US$) of Kazakhstan and Value added (current US$) of Tuvalu?
Ensure brevity in your answer.  7.18e+1. In the year 2011, what is the difference between the Value added (current US$) of Kazakhstan and Value added (current US$) of Zambia?
Your answer should be very brief. 6.37e+1. In the year 2011, what is the difference between the Value added (current US$) of Rwanda and Value added (current US$) of Tuvalu?
Offer a terse response. 9.19e+08. In the year 2011, what is the difference between the Value added (current US$) of Rwanda and Value added (current US$) of Zambia?
Your answer should be very brief. -7.13e+09. In the year 2011, what is the difference between the Value added (current US$) of Tuvalu and Value added (current US$) of Zambia?
Make the answer very short. -8.05e+09. In the year 2012, what is the difference between the Value added (current US$) of Kazakhstan and Value added (current US$) of Rwanda?
Provide a succinct answer. 7.45e+1. In the year 2012, what is the difference between the Value added (current US$) in Kazakhstan and Value added (current US$) in Tuvalu?
Your response must be concise. 7.55e+1. In the year 2012, what is the difference between the Value added (current US$) in Kazakhstan and Value added (current US$) in Zambia?
Provide a short and direct response. 6.74e+1. In the year 2012, what is the difference between the Value added (current US$) in Rwanda and Value added (current US$) in Tuvalu?
Your answer should be very brief. 1.04e+09. In the year 2012, what is the difference between the Value added (current US$) of Rwanda and Value added (current US$) of Zambia?
Keep it short and to the point. -7.03e+09. In the year 2012, what is the difference between the Value added (current US$) of Tuvalu and Value added (current US$) of Zambia?
Give a very brief answer. -8.06e+09. What is the ratio of the Value added (current US$) in Kazakhstan in 2005 to that in 2006?
Ensure brevity in your answer.  0.67. What is the ratio of the Value added (current US$) of Rwanda in 2005 to that in 2006?
Offer a very short reply. 0.85. What is the ratio of the Value added (current US$) in Tuvalu in 2005 to that in 2006?
Offer a very short reply. 1.31. What is the ratio of the Value added (current US$) in Zambia in 2005 to that in 2006?
Provide a succinct answer. 0.58. What is the ratio of the Value added (current US$) in Kazakhstan in 2005 to that in 2007?
Offer a very short reply. 0.54. What is the ratio of the Value added (current US$) of Rwanda in 2005 to that in 2007?
Your answer should be compact. 0.65. What is the ratio of the Value added (current US$) of Tuvalu in 2005 to that in 2007?
Keep it short and to the point. 0.8. What is the ratio of the Value added (current US$) of Zambia in 2005 to that in 2007?
Give a very brief answer. 0.5. What is the ratio of the Value added (current US$) of Kazakhstan in 2005 to that in 2008?
Your response must be concise. 0.4. What is the ratio of the Value added (current US$) in Rwanda in 2005 to that in 2008?
Give a very brief answer. 0.5. What is the ratio of the Value added (current US$) of Tuvalu in 2005 to that in 2008?
Your answer should be compact. 0.43. What is the ratio of the Value added (current US$) in Zambia in 2005 to that in 2008?
Give a very brief answer. 0.4. What is the ratio of the Value added (current US$) of Kazakhstan in 2005 to that in 2009?
Your answer should be very brief. 0.48. What is the ratio of the Value added (current US$) in Rwanda in 2005 to that in 2009?
Provide a succinct answer. 0.47. What is the ratio of the Value added (current US$) in Tuvalu in 2005 to that in 2009?
Provide a short and direct response. 0.55. What is the ratio of the Value added (current US$) of Zambia in 2005 to that in 2009?
Give a very brief answer. 0.48. What is the ratio of the Value added (current US$) in Kazakhstan in 2005 to that in 2010?
Your answer should be compact. 0.36. What is the ratio of the Value added (current US$) of Rwanda in 2005 to that in 2010?
Your response must be concise. 0.42. What is the ratio of the Value added (current US$) in Tuvalu in 2005 to that in 2010?
Make the answer very short. 0.96. What is the ratio of the Value added (current US$) in Zambia in 2005 to that in 2010?
Your response must be concise. 0.33. What is the ratio of the Value added (current US$) of Kazakhstan in 2005 to that in 2011?
Your answer should be very brief. 0.3. What is the ratio of the Value added (current US$) in Rwanda in 2005 to that in 2011?
Your response must be concise. 0.33. What is the ratio of the Value added (current US$) in Tuvalu in 2005 to that in 2011?
Make the answer very short. 0.49. What is the ratio of the Value added (current US$) of Zambia in 2005 to that in 2011?
Your response must be concise. 0.28. What is the ratio of the Value added (current US$) of Kazakhstan in 2005 to that in 2012?
Offer a very short reply. 0.28. What is the ratio of the Value added (current US$) in Rwanda in 2005 to that in 2012?
Offer a terse response. 0.29. What is the ratio of the Value added (current US$) of Tuvalu in 2005 to that in 2012?
Ensure brevity in your answer.  0.78. What is the ratio of the Value added (current US$) of Zambia in 2005 to that in 2012?
Make the answer very short. 0.28. What is the ratio of the Value added (current US$) in Kazakhstan in 2006 to that in 2007?
Your response must be concise. 0.81. What is the ratio of the Value added (current US$) of Rwanda in 2006 to that in 2007?
Your response must be concise. 0.77. What is the ratio of the Value added (current US$) of Tuvalu in 2006 to that in 2007?
Your answer should be very brief. 0.61. What is the ratio of the Value added (current US$) of Zambia in 2006 to that in 2007?
Your answer should be compact. 0.86. What is the ratio of the Value added (current US$) in Kazakhstan in 2006 to that in 2008?
Provide a short and direct response. 0.59. What is the ratio of the Value added (current US$) in Rwanda in 2006 to that in 2008?
Give a very brief answer. 0.59. What is the ratio of the Value added (current US$) in Tuvalu in 2006 to that in 2008?
Keep it short and to the point. 0.33. What is the ratio of the Value added (current US$) of Zambia in 2006 to that in 2008?
Provide a short and direct response. 0.7. What is the ratio of the Value added (current US$) of Kazakhstan in 2006 to that in 2009?
Provide a succinct answer. 0.72. What is the ratio of the Value added (current US$) of Rwanda in 2006 to that in 2009?
Offer a terse response. 0.55. What is the ratio of the Value added (current US$) of Tuvalu in 2006 to that in 2009?
Offer a terse response. 0.42. What is the ratio of the Value added (current US$) in Zambia in 2006 to that in 2009?
Ensure brevity in your answer.  0.84. What is the ratio of the Value added (current US$) in Kazakhstan in 2006 to that in 2010?
Provide a short and direct response. 0.53. What is the ratio of the Value added (current US$) of Rwanda in 2006 to that in 2010?
Your answer should be very brief. 0.49. What is the ratio of the Value added (current US$) in Tuvalu in 2006 to that in 2010?
Offer a terse response. 0.73. What is the ratio of the Value added (current US$) of Zambia in 2006 to that in 2010?
Ensure brevity in your answer.  0.57. What is the ratio of the Value added (current US$) of Kazakhstan in 2006 to that in 2011?
Your answer should be compact. 0.44. What is the ratio of the Value added (current US$) in Rwanda in 2006 to that in 2011?
Your response must be concise. 0.39. What is the ratio of the Value added (current US$) of Tuvalu in 2006 to that in 2011?
Give a very brief answer. 0.37. What is the ratio of the Value added (current US$) in Zambia in 2006 to that in 2011?
Give a very brief answer. 0.48. What is the ratio of the Value added (current US$) of Kazakhstan in 2006 to that in 2012?
Ensure brevity in your answer.  0.42. What is the ratio of the Value added (current US$) in Rwanda in 2006 to that in 2012?
Keep it short and to the point. 0.35. What is the ratio of the Value added (current US$) in Tuvalu in 2006 to that in 2012?
Keep it short and to the point. 0.6. What is the ratio of the Value added (current US$) of Zambia in 2006 to that in 2012?
Keep it short and to the point. 0.48. What is the ratio of the Value added (current US$) in Kazakhstan in 2007 to that in 2008?
Your response must be concise. 0.74. What is the ratio of the Value added (current US$) in Rwanda in 2007 to that in 2008?
Offer a very short reply. 0.77. What is the ratio of the Value added (current US$) in Tuvalu in 2007 to that in 2008?
Provide a succinct answer. 0.54. What is the ratio of the Value added (current US$) of Zambia in 2007 to that in 2008?
Your response must be concise. 0.81. What is the ratio of the Value added (current US$) in Kazakhstan in 2007 to that in 2009?
Your answer should be very brief. 0.89. What is the ratio of the Value added (current US$) in Rwanda in 2007 to that in 2009?
Provide a short and direct response. 0.71. What is the ratio of the Value added (current US$) in Tuvalu in 2007 to that in 2009?
Offer a terse response. 0.68. What is the ratio of the Value added (current US$) in Zambia in 2007 to that in 2009?
Offer a very short reply. 0.97. What is the ratio of the Value added (current US$) in Kazakhstan in 2007 to that in 2010?
Offer a terse response. 0.66. What is the ratio of the Value added (current US$) in Rwanda in 2007 to that in 2010?
Your response must be concise. 0.64. What is the ratio of the Value added (current US$) of Tuvalu in 2007 to that in 2010?
Provide a succinct answer. 1.19. What is the ratio of the Value added (current US$) in Zambia in 2007 to that in 2010?
Your response must be concise. 0.66. What is the ratio of the Value added (current US$) in Kazakhstan in 2007 to that in 2011?
Your response must be concise. 0.55. What is the ratio of the Value added (current US$) of Rwanda in 2007 to that in 2011?
Your response must be concise. 0.51. What is the ratio of the Value added (current US$) of Tuvalu in 2007 to that in 2011?
Make the answer very short. 0.61. What is the ratio of the Value added (current US$) in Zambia in 2007 to that in 2011?
Make the answer very short. 0.56. What is the ratio of the Value added (current US$) in Kazakhstan in 2007 to that in 2012?
Provide a succinct answer. 0.52. What is the ratio of the Value added (current US$) in Rwanda in 2007 to that in 2012?
Offer a terse response. 0.45. What is the ratio of the Value added (current US$) of Tuvalu in 2007 to that in 2012?
Offer a very short reply. 0.98. What is the ratio of the Value added (current US$) of Zambia in 2007 to that in 2012?
Offer a very short reply. 0.56. What is the ratio of the Value added (current US$) of Kazakhstan in 2008 to that in 2009?
Offer a very short reply. 1.21. What is the ratio of the Value added (current US$) in Rwanda in 2008 to that in 2009?
Offer a very short reply. 0.92. What is the ratio of the Value added (current US$) of Tuvalu in 2008 to that in 2009?
Ensure brevity in your answer.  1.26. What is the ratio of the Value added (current US$) of Zambia in 2008 to that in 2009?
Your answer should be compact. 1.2. What is the ratio of the Value added (current US$) in Kazakhstan in 2008 to that in 2010?
Make the answer very short. 0.89. What is the ratio of the Value added (current US$) of Rwanda in 2008 to that in 2010?
Keep it short and to the point. 0.82. What is the ratio of the Value added (current US$) in Tuvalu in 2008 to that in 2010?
Offer a terse response. 2.2. What is the ratio of the Value added (current US$) in Zambia in 2008 to that in 2010?
Your answer should be compact. 0.82. What is the ratio of the Value added (current US$) in Kazakhstan in 2008 to that in 2011?
Offer a terse response. 0.75. What is the ratio of the Value added (current US$) in Rwanda in 2008 to that in 2011?
Ensure brevity in your answer.  0.66. What is the ratio of the Value added (current US$) of Tuvalu in 2008 to that in 2011?
Offer a terse response. 1.12. What is the ratio of the Value added (current US$) of Zambia in 2008 to that in 2011?
Offer a terse response. 0.69. What is the ratio of the Value added (current US$) of Kazakhstan in 2008 to that in 2012?
Make the answer very short. 0.71. What is the ratio of the Value added (current US$) in Rwanda in 2008 to that in 2012?
Keep it short and to the point. 0.58. What is the ratio of the Value added (current US$) of Tuvalu in 2008 to that in 2012?
Ensure brevity in your answer.  1.8. What is the ratio of the Value added (current US$) in Zambia in 2008 to that in 2012?
Your answer should be compact. 0.69. What is the ratio of the Value added (current US$) of Kazakhstan in 2009 to that in 2010?
Provide a succinct answer. 0.74. What is the ratio of the Value added (current US$) of Rwanda in 2009 to that in 2010?
Provide a short and direct response. 0.89. What is the ratio of the Value added (current US$) in Tuvalu in 2009 to that in 2010?
Offer a terse response. 1.75. What is the ratio of the Value added (current US$) in Zambia in 2009 to that in 2010?
Your answer should be very brief. 0.68. What is the ratio of the Value added (current US$) in Kazakhstan in 2009 to that in 2011?
Your answer should be compact. 0.62. What is the ratio of the Value added (current US$) in Rwanda in 2009 to that in 2011?
Provide a succinct answer. 0.71. What is the ratio of the Value added (current US$) of Tuvalu in 2009 to that in 2011?
Keep it short and to the point. 0.89. What is the ratio of the Value added (current US$) of Zambia in 2009 to that in 2011?
Offer a very short reply. 0.58. What is the ratio of the Value added (current US$) in Kazakhstan in 2009 to that in 2012?
Make the answer very short. 0.59. What is the ratio of the Value added (current US$) in Rwanda in 2009 to that in 2012?
Your answer should be compact. 0.63. What is the ratio of the Value added (current US$) in Tuvalu in 2009 to that in 2012?
Provide a succinct answer. 1.43. What is the ratio of the Value added (current US$) in Zambia in 2009 to that in 2012?
Keep it short and to the point. 0.57. What is the ratio of the Value added (current US$) in Kazakhstan in 2010 to that in 2011?
Ensure brevity in your answer.  0.84. What is the ratio of the Value added (current US$) in Rwanda in 2010 to that in 2011?
Ensure brevity in your answer.  0.8. What is the ratio of the Value added (current US$) in Tuvalu in 2010 to that in 2011?
Provide a short and direct response. 0.51. What is the ratio of the Value added (current US$) in Zambia in 2010 to that in 2011?
Give a very brief answer. 0.84. What is the ratio of the Value added (current US$) of Kazakhstan in 2010 to that in 2012?
Give a very brief answer. 0.8. What is the ratio of the Value added (current US$) of Rwanda in 2010 to that in 2012?
Your response must be concise. 0.71. What is the ratio of the Value added (current US$) in Tuvalu in 2010 to that in 2012?
Offer a terse response. 0.82. What is the ratio of the Value added (current US$) in Zambia in 2010 to that in 2012?
Provide a short and direct response. 0.84. What is the ratio of the Value added (current US$) of Kazakhstan in 2011 to that in 2012?
Keep it short and to the point. 0.95. What is the ratio of the Value added (current US$) of Rwanda in 2011 to that in 2012?
Provide a succinct answer. 0.89. What is the ratio of the Value added (current US$) of Tuvalu in 2011 to that in 2012?
Provide a succinct answer. 1.61. What is the ratio of the Value added (current US$) in Zambia in 2011 to that in 2012?
Ensure brevity in your answer.  1. What is the difference between the highest and the second highest Value added (current US$) in Kazakhstan?
Keep it short and to the point. 3.73e+09. What is the difference between the highest and the second highest Value added (current US$) of Rwanda?
Provide a succinct answer. 1.16e+08. What is the difference between the highest and the second highest Value added (current US$) of Tuvalu?
Offer a very short reply. 4.23e+05. What is the difference between the highest and the second highest Value added (current US$) in Zambia?
Your answer should be compact. 1.27e+07. What is the difference between the highest and the lowest Value added (current US$) in Kazakhstan?
Your answer should be compact. 5.40e+1. What is the difference between the highest and the lowest Value added (current US$) in Rwanda?
Ensure brevity in your answer.  7.34e+08. What is the difference between the highest and the lowest Value added (current US$) of Tuvalu?
Keep it short and to the point. 2.61e+06. What is the difference between the highest and the lowest Value added (current US$) in Zambia?
Give a very brief answer. 5.83e+09. 